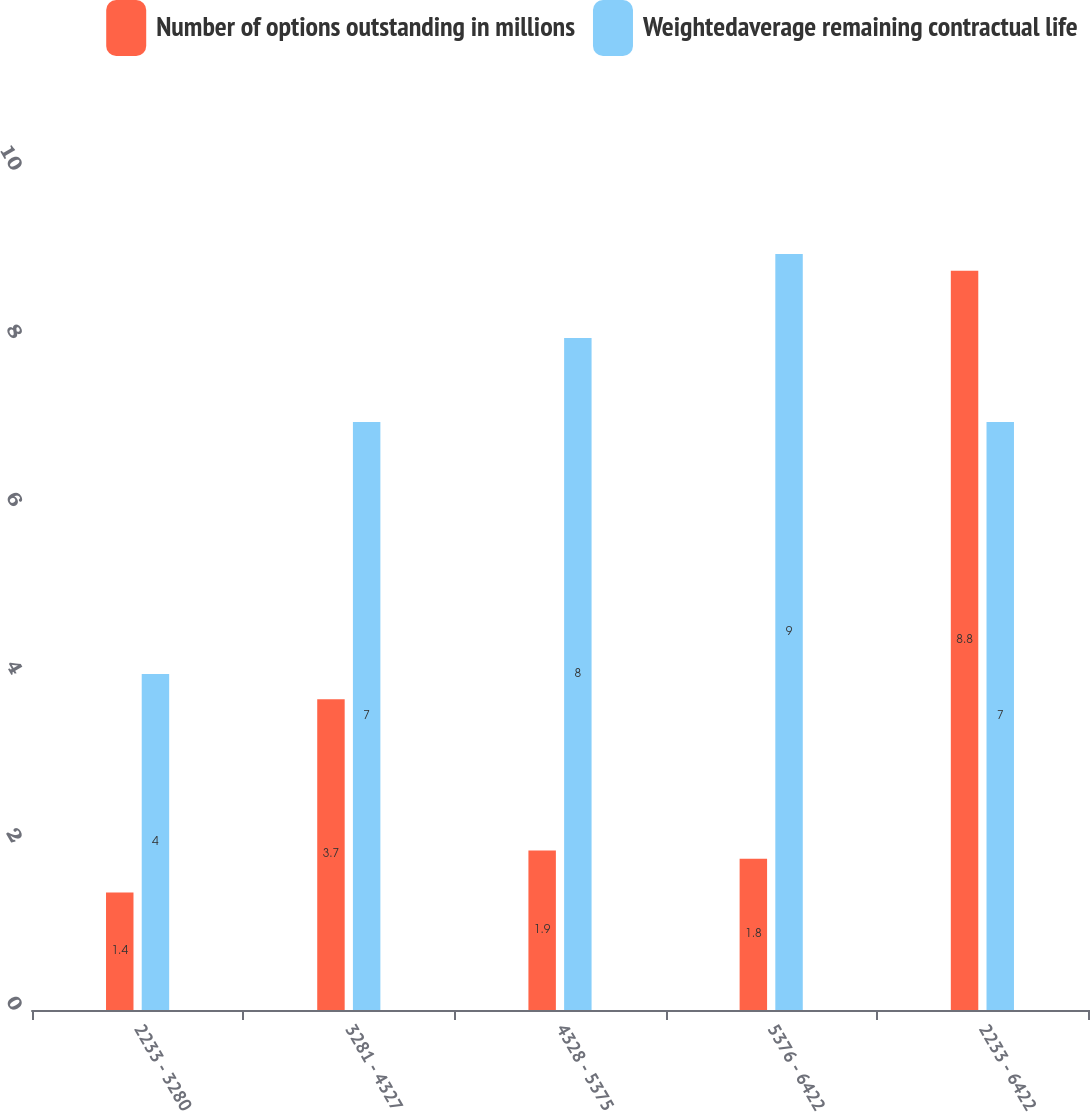Convert chart to OTSL. <chart><loc_0><loc_0><loc_500><loc_500><stacked_bar_chart><ecel><fcel>2233 - 3280<fcel>3281 - 4327<fcel>4328 - 5375<fcel>5376 - 6422<fcel>2233 - 6422<nl><fcel>Number of options outstanding in millions<fcel>1.4<fcel>3.7<fcel>1.9<fcel>1.8<fcel>8.8<nl><fcel>Weightedaverage remaining contractual life<fcel>4<fcel>7<fcel>8<fcel>9<fcel>7<nl></chart> 